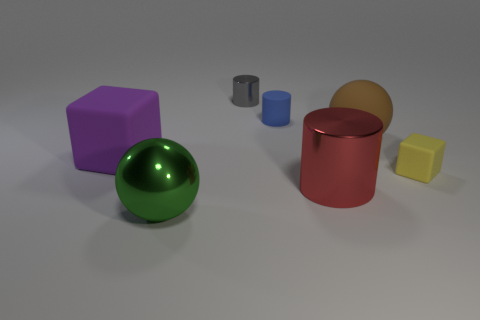What is the big brown sphere made of?
Your answer should be very brief. Rubber. There is a matte thing that is to the left of the large brown object and to the right of the green shiny thing; what is its size?
Your response must be concise. Small. What number of large gray metallic cubes are there?
Ensure brevity in your answer.  0. Are there fewer gray things than big brown cylinders?
Offer a very short reply. No. There is a brown object that is the same size as the red object; what is it made of?
Give a very brief answer. Rubber. How many things are either small objects or small red blocks?
Your answer should be very brief. 3. How many large things are left of the tiny blue matte object and behind the large red shiny thing?
Provide a succinct answer. 1. Is the number of tiny rubber objects left of the red metal cylinder less than the number of blue spheres?
Your answer should be very brief. No. There is a brown object that is the same size as the green shiny thing; what is its shape?
Offer a very short reply. Sphere. How many other objects are there of the same color as the big cylinder?
Your response must be concise. 0. 